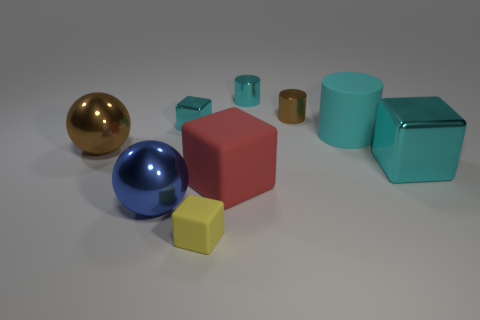Subtract all small cyan cylinders. How many cylinders are left? 2 Subtract 2 cubes. How many cubes are left? 2 Add 1 small matte blocks. How many objects exist? 10 Subtract all red blocks. How many blocks are left? 3 Subtract all yellow cylinders. Subtract all green spheres. How many cylinders are left? 3 Subtract all tiny cyan metal blocks. Subtract all shiny balls. How many objects are left? 6 Add 7 large blue objects. How many large blue objects are left? 8 Add 9 large brown metallic things. How many large brown metallic things exist? 10 Subtract 1 blue spheres. How many objects are left? 8 Subtract all cylinders. How many objects are left? 6 